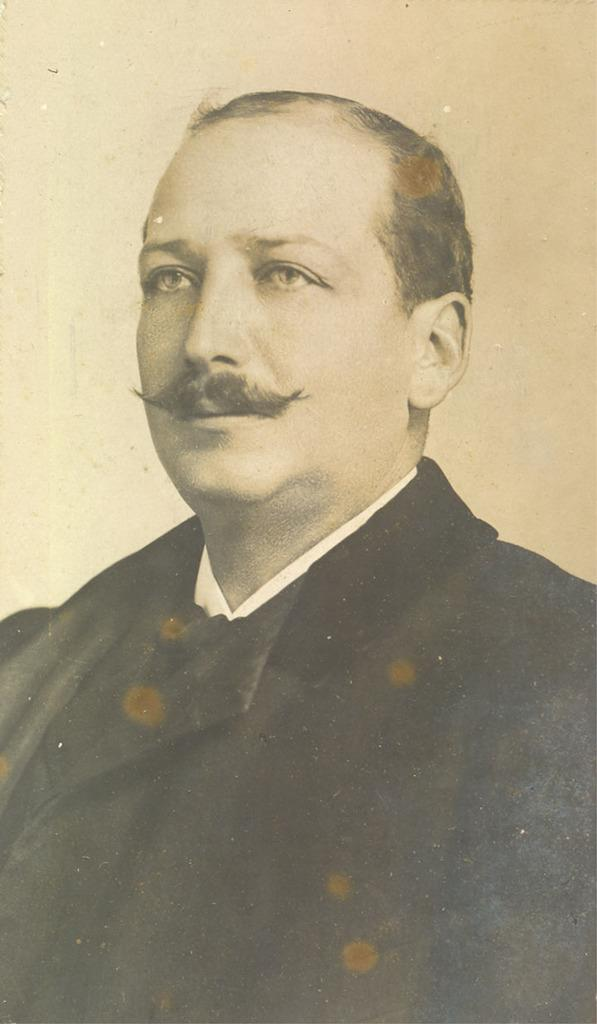What is the main subject of the image? There is a person in the image. What is the color scheme of the image? The image is in black and white. How many steps does the person take in the image? There is no indication of the person taking any steps in the image, as it is a still photograph. Does the existence of the person in the image prove the existence of extraterrestrial life? The presence of a person in the image does not prove the existence of extraterrestrial life, as the image only shows a person on Earth. 